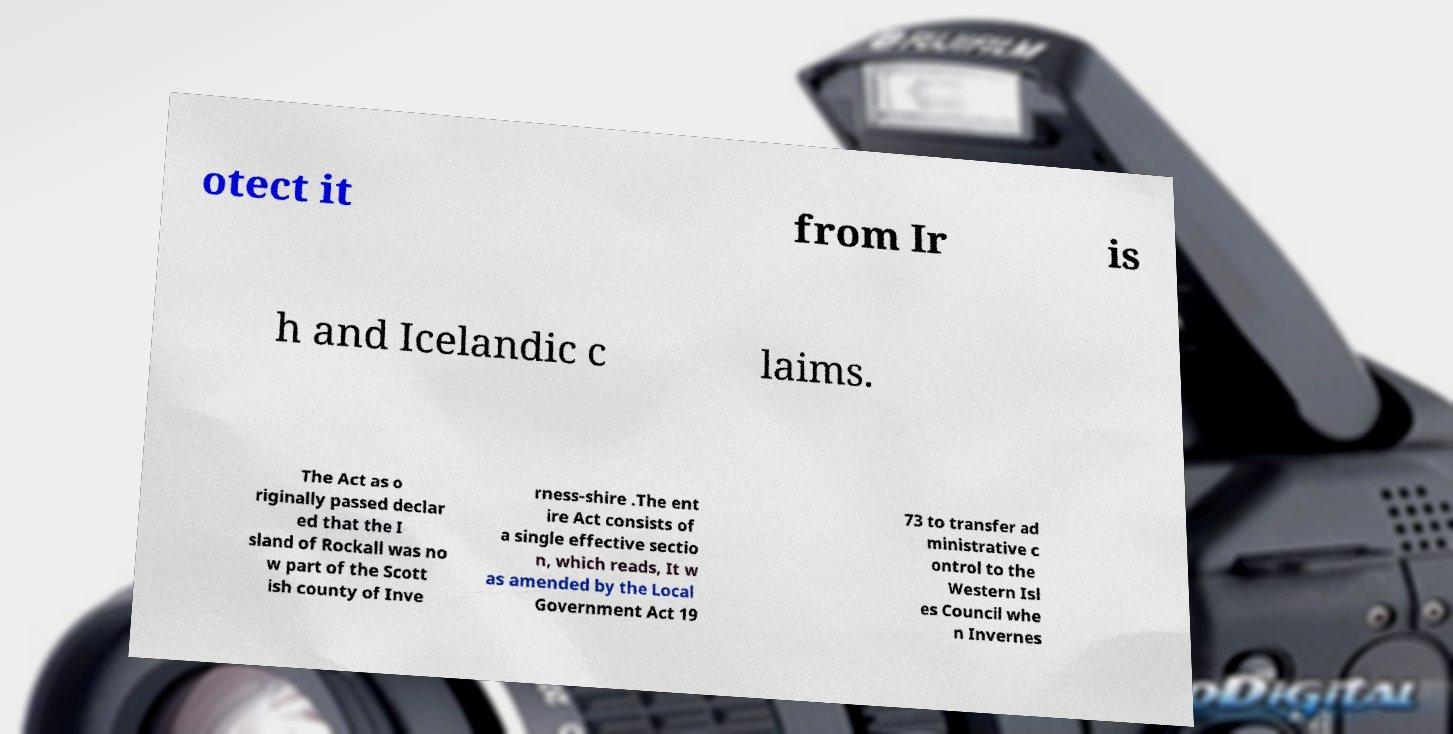I need the written content from this picture converted into text. Can you do that? otect it from Ir is h and Icelandic c laims. The Act as o riginally passed declar ed that the I sland of Rockall was no w part of the Scott ish county of Inve rness-shire .The ent ire Act consists of a single effective sectio n, which reads, It w as amended by the Local Government Act 19 73 to transfer ad ministrative c ontrol to the Western Isl es Council whe n Invernes 